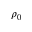Convert formula to latex. <formula><loc_0><loc_0><loc_500><loc_500>\rho _ { 0 }</formula> 